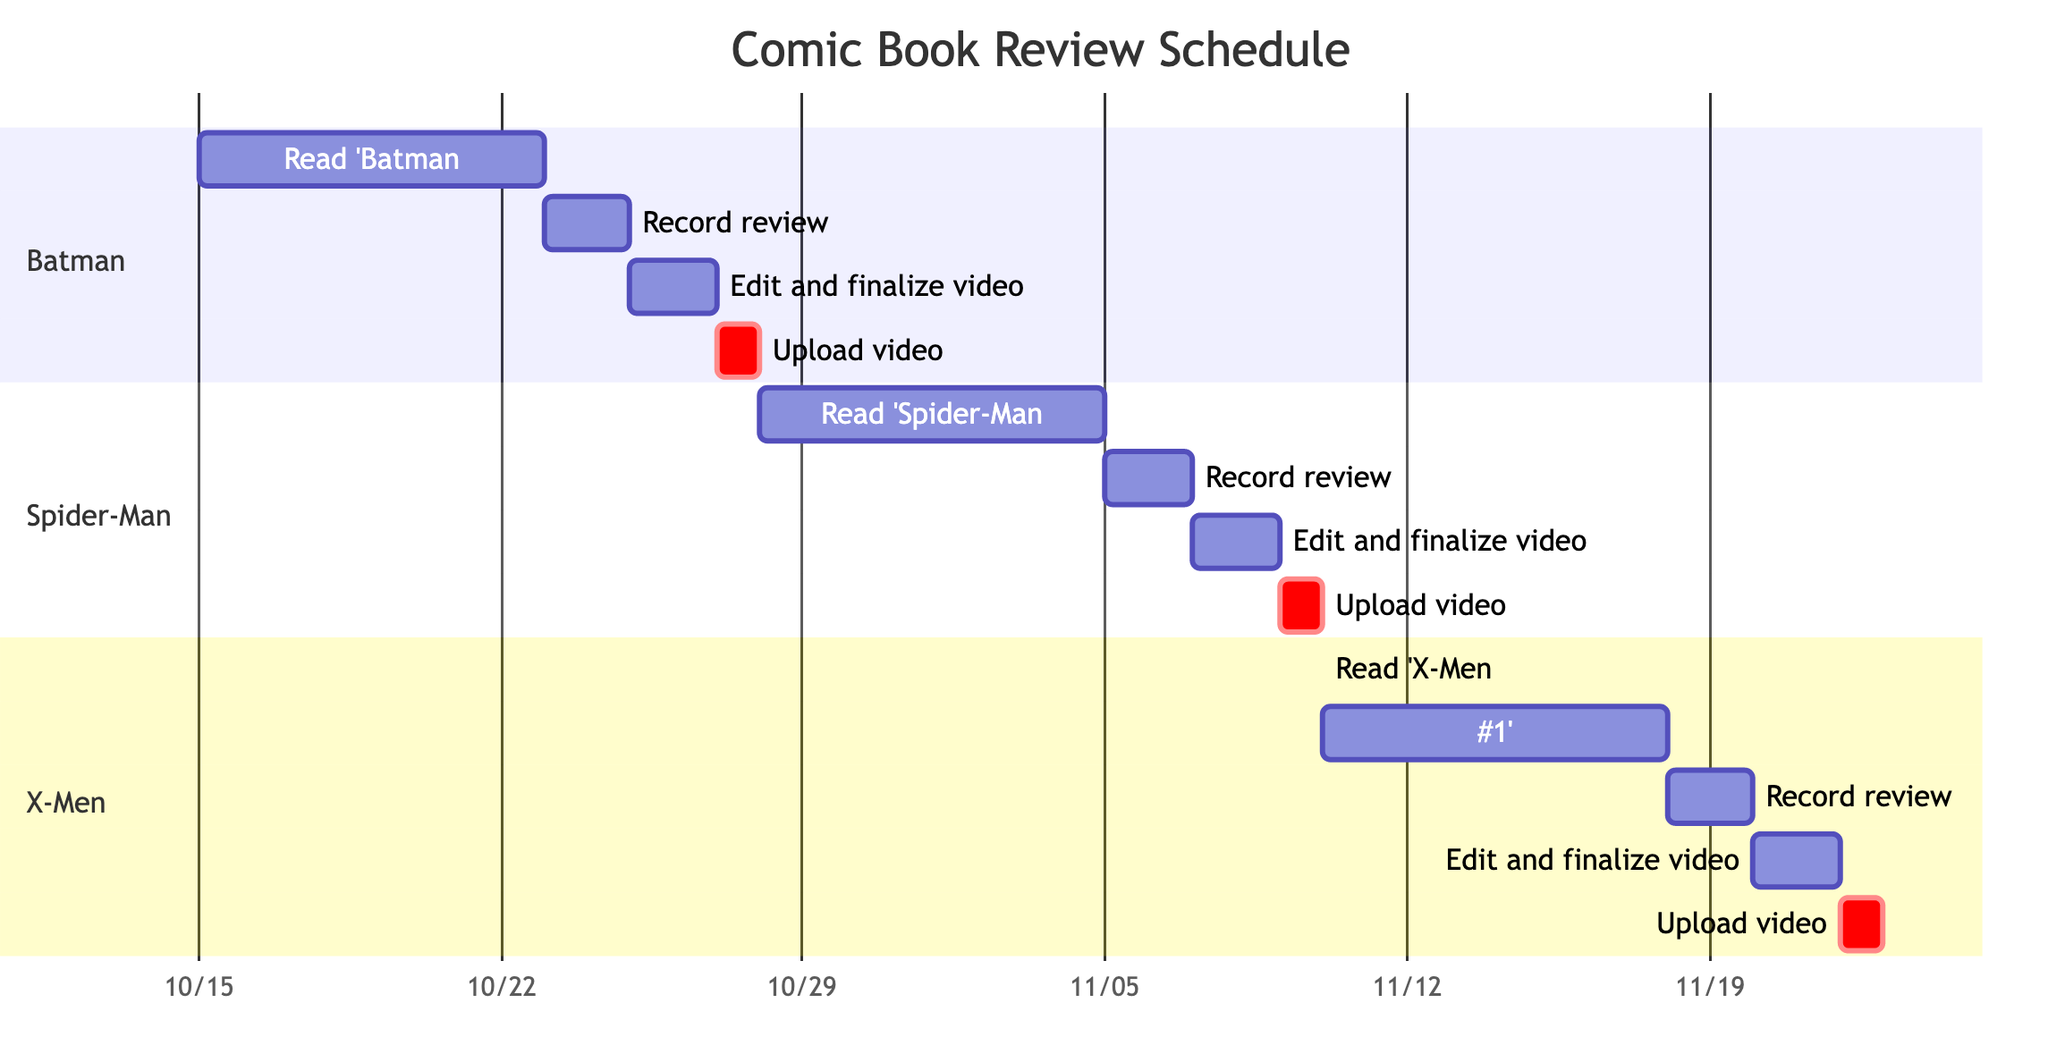What is the duration of the reading period for 'Batman: One Bad Day – The Riddler'? The task 'Read 'Batman: One Bad Day – The Riddler'' spans from October 15 to October 22, which is 8 days in duration.
Answer: 8 days What is the start date for recording the review of 'Spider-Man: The Hunt for Spider-Man'? The task 'Record review for 'Spider-Man: The Hunt for Spider-Man'' starts on November 5, 2023.
Answer: November 5, 2023 Which comic book has its video upload date on November 22, 2023? The task 'Upload video for 'X-Men: Red #1'' is scheduled for November 22, 2023.
Answer: X-Men: Red #1 How many days are allocated for editing the video of 'X-Men: Red #1'? The task 'Edit and finalize video for 'X-Men: Red #1'' is scheduled for November 20 to November 21, which is 2 days.
Answer: 2 days Which comic book's review recording overlaps with the reading period of 'X-Men: Red #1'? The reading period for 'X-Men: Red #1' occurs from November 10 to November 17. The review recording for 'Spider-Man: The Hunt for Spider-Man' occurs from November 5 to November 6, which does not overlap. However, 'X-Men: Red #1' recording is from November 18 to November 19, overlapping with the completion of the previous book's reading.
Answer: Spider-Man: The Hunt for Spider-Man What is the total number of tasks listed for each comic title? Each title has 4 tasks: reading, recording, editing, and uploading. This totals to 3 titles with 4 tasks each, resulting in 12 tasks overall.
Answer: 12 tasks Which section has the earliest upload date? The section for 'Batman' has its upload date on October 27, 2023, which is earlier than any other upload dates listed.
Answer: Batman What is the final task of the Gantt Chart? The last task listed within the chart is 'Upload video for 'X-Men: Red #1''.
Answer: Upload video for 'X-Men: Red #1' 